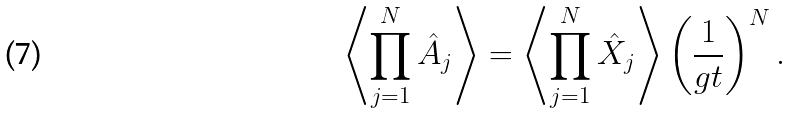<formula> <loc_0><loc_0><loc_500><loc_500>\left \langle \prod _ { j = 1 } ^ { N } \hat { A } _ { j } \right \rangle = \left \langle \prod _ { j = 1 } ^ { N } \hat { X } _ { j } \right \rangle \left ( \frac { 1 } { g t } \right ) ^ { N } .</formula> 